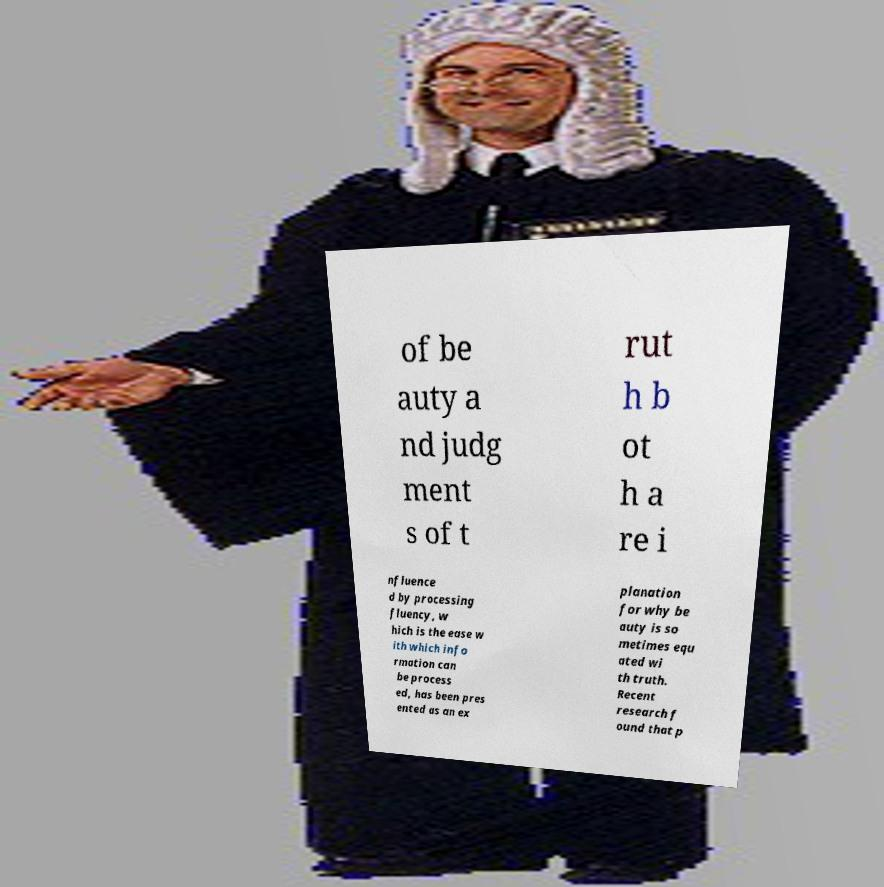Could you extract and type out the text from this image? of be auty a nd judg ment s of t rut h b ot h a re i nfluence d by processing fluency, w hich is the ease w ith which info rmation can be process ed, has been pres ented as an ex planation for why be auty is so metimes equ ated wi th truth. Recent research f ound that p 